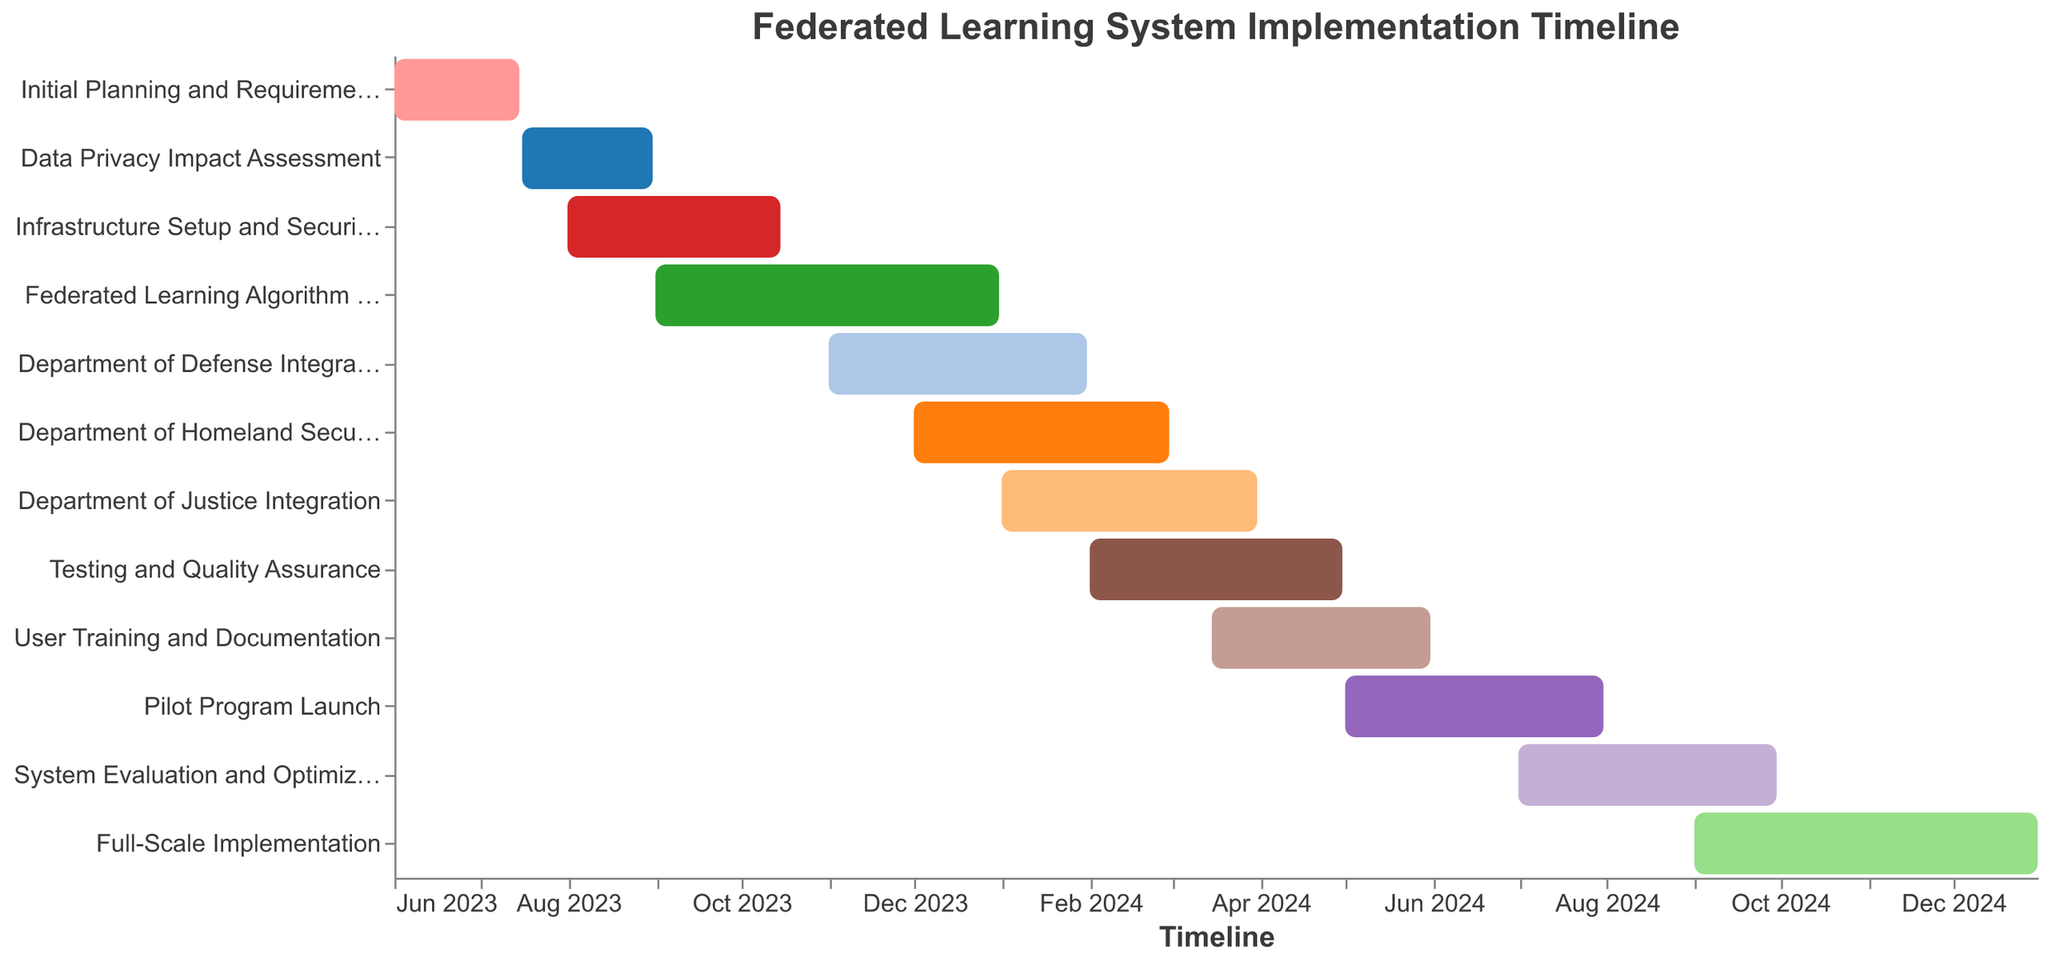What is the title of the Gantt Chart? The title of the Gantt Chart is displayed at the top of the figure.
Answer: Federated Learning System Implementation Timeline When does the "Initial Planning and Requirements Gathering" start and end? Look for the "Initial Planning and Requirements Gathering" task bar at the top and check its start and end dates.
Answer: Starts on June 1, 2023, and ends on July 15, 2023 Which tasks are planned to be completed in January 2024? Check the timeline and identify the tasks that have an end date within January 2024.
Answer: Department of Defense Integration and Department of Homeland Security Integration How many tasks span across both 2023 and 2024? Look at the tasks and check which ones start in 2023 and end in 2024.
Answer: There are four tasks: Federated Learning Algorithm Development, Department of Defense Integration, Department of Homeland Security Integration, and Department of Justice Integration What is the color of the task "User Training and Documentation"? Identify the task "User Training and Documentation" and note its color from the color scheme used in the chart.
Answer: The specific color can be seen on the chart; it is from the "category20" color scheme Which task has the longest duration? Count the number of months each task spans and find the task with the longest period between its start and end dates.
Answer: Federated Learning Algorithm Development (4 months) Which tasks overlap with "Testing and Quality Assurance"? Identify the time span of "Testing and Quality Assurance" and find tasks that share this timeline.
Answer: Department of Justice Integration, User Training and Documentation, and Pilot Program Launch When does the "Full-Scale Implementation" begin and end? Locate the "Full-Scale Implementation" task bar at the bottom and note its start and end dates.
Answer: Starts on September 1, 2024, and ends on December 31, 2024 Which tasks are scheduled to start in February 2024? Check the timeline for February 2024 and note any tasks that start in this month.
Answer: Testing and Quality Assurance What is the total duration for the entire project timeline? Identify the start date of the first task and the end date of the last task, then calculate the total duration in months.
Answer: The project starts on June 1, 2023, and ends on December 31, 2024, making the total duration approximately 19 months 